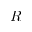Convert formula to latex. <formula><loc_0><loc_0><loc_500><loc_500>R</formula> 